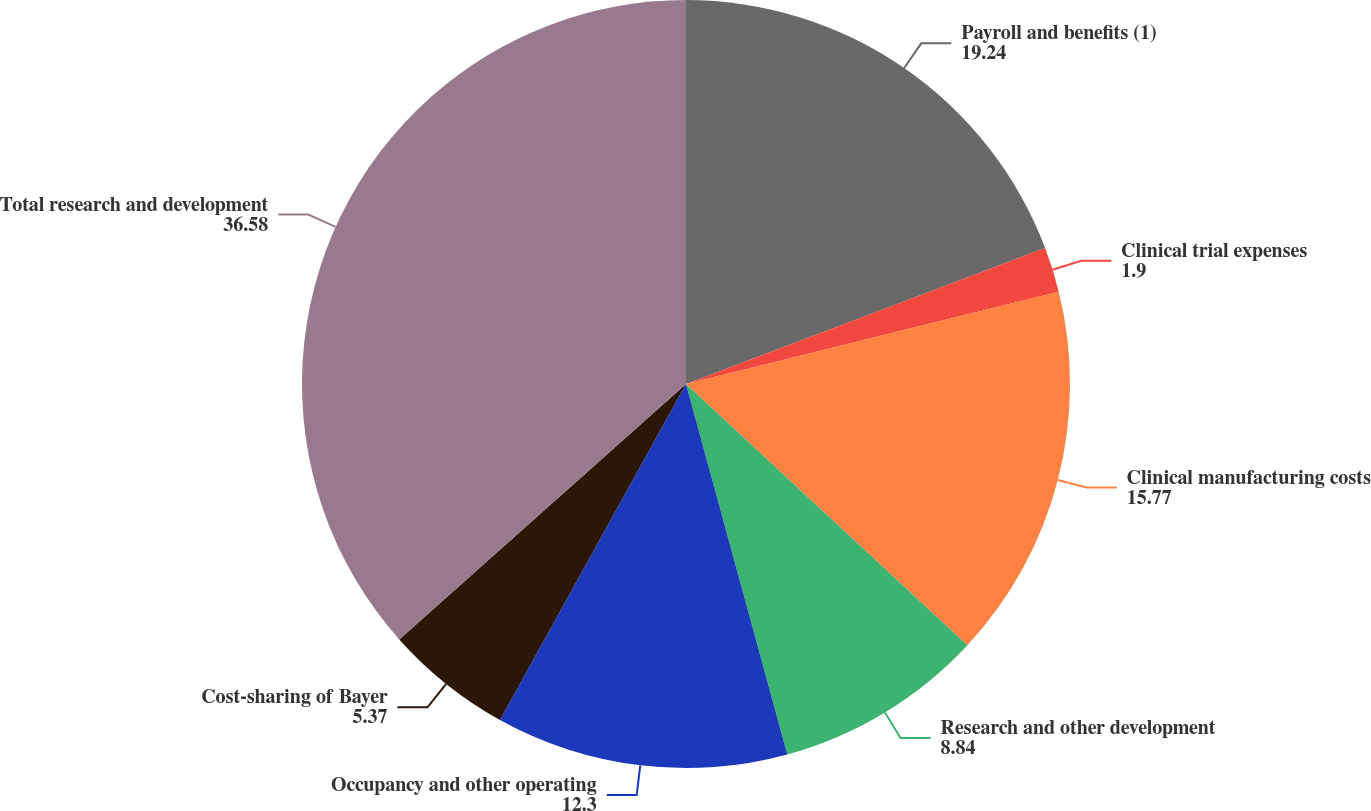Convert chart. <chart><loc_0><loc_0><loc_500><loc_500><pie_chart><fcel>Payroll and benefits (1)<fcel>Clinical trial expenses<fcel>Clinical manufacturing costs<fcel>Research and other development<fcel>Occupancy and other operating<fcel>Cost-sharing of Bayer<fcel>Total research and development<nl><fcel>19.24%<fcel>1.9%<fcel>15.77%<fcel>8.84%<fcel>12.3%<fcel>5.37%<fcel>36.58%<nl></chart> 